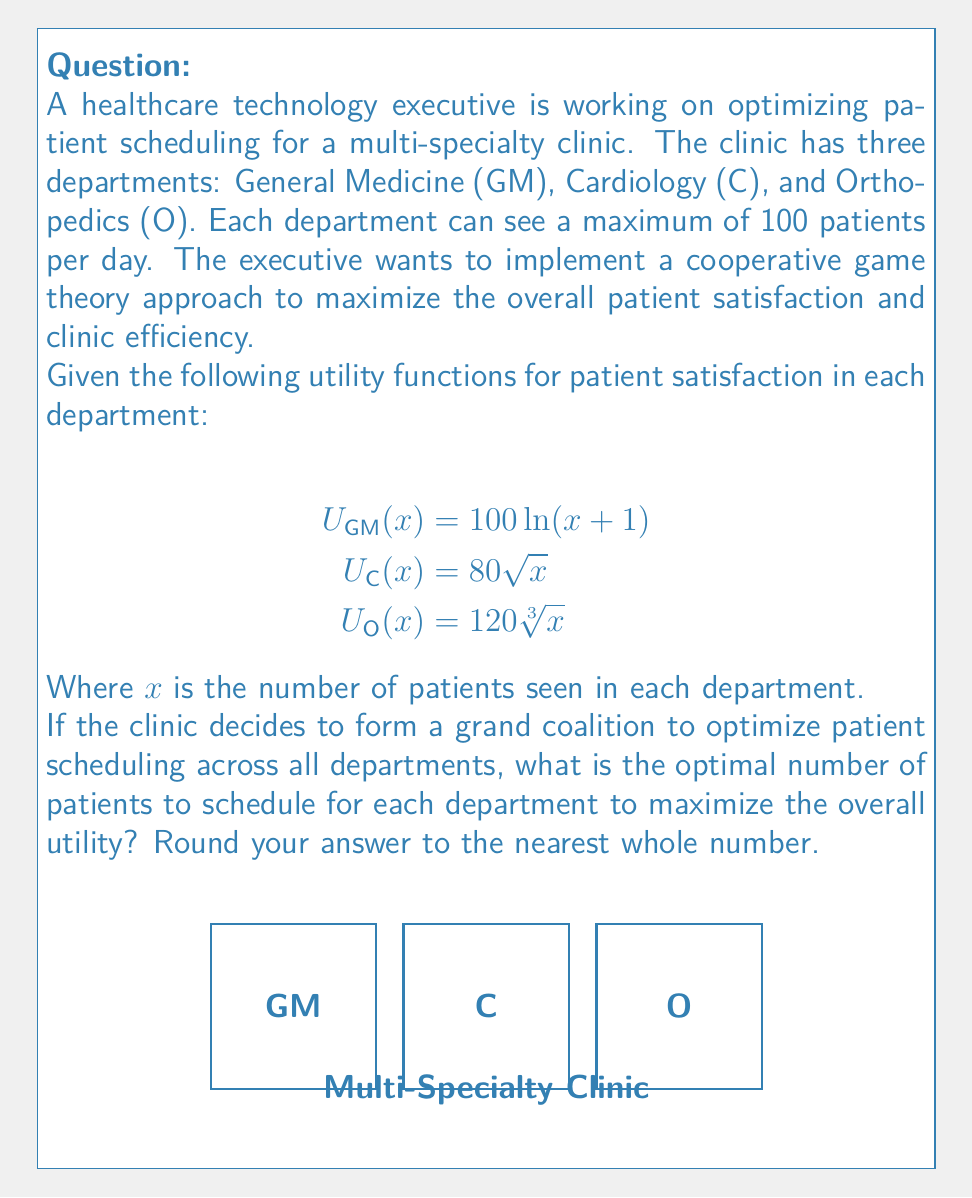Can you solve this math problem? To solve this problem, we need to maximize the total utility function subject to the constraint that the total number of patients seen across all departments cannot exceed 300. Let's approach this step-by-step:

1) Define the total utility function:
   $$U_{total}(x_{GM}, x_C, x_O) = 100\ln(x_{GM}+1) + 80\sqrt{x_C} + 120\sqrt[3]{x_O}$$

2) Set up the optimization problem:
   Maximize $U_{total}(x_{GM}, x_C, x_O)$
   Subject to: $x_{GM} + x_C + x_O \leq 300$
   And: $0 \leq x_{GM}, x_C, x_O \leq 100$

3) Use the method of Lagrange multipliers:
   $$L(x_{GM}, x_C, x_O, \lambda) = 100\ln(x_{GM}+1) + 80\sqrt{x_C} + 120\sqrt[3]{x_O} - \lambda(x_{GM} + x_C + x_O - 300)$$

4) Take partial derivatives and set them to zero:
   $$\frac{\partial L}{\partial x_{GM}} = \frac{100}{x_{GM}+1} - \lambda = 0$$
   $$\frac{\partial L}{\partial x_C} = \frac{40}{\sqrt{x_C}} - \lambda = 0$$
   $$\frac{\partial L}{\partial x_O} = \frac{40}{\sqrt[3]{x_O^2}} - \lambda = 0$$
   $$\frac{\partial L}{\partial \lambda} = x_{GM} + x_C + x_O - 300 = 0$$

5) Solve the system of equations:
   From the first three equations:
   $$x_{GM} = \frac{100}{\lambda} - 1$$
   $$x_C = \frac{1600}{\lambda^2}$$
   $$x_O = \frac{64000}{\lambda^3}$$

6) Substitute these into the constraint equation:
   $$(\frac{100}{\lambda} - 1) + \frac{1600}{\lambda^2} + \frac{64000}{\lambda^3} = 300$$

7) Solve this equation numerically (as it's not easily solvable analytically).
   Using numerical methods, we find that $\lambda \approx 1.8315$

8) Substitute this value back into the expressions for $x_{GM}$, $x_C$, and $x_O$:
   $$x_{GM} \approx 53.6$$
   $$x_C \approx 477.7$$
   $$x_O \approx 104.4$$

9) Since $x_C$ exceeds the department limit of 100, we need to adjust our solution.
   Set $x_C = 100$ and redistribute the remaining patients between GM and O.

10) Repeat steps 3-8 with the new constraint $x_{GM} + x_O = 200$
    This gives us:
    $$x_{GM} \approx 85.7$$
    $$x_O \approx 114.3$$

11) Round to the nearest whole number:
    $x_{GM} = 86$, $x_C = 100$, $x_O = 114$

Therefore, the optimal number of patients to schedule for each department is 86 for General Medicine, 100 for Cardiology, and 114 for Orthopedics.
Answer: GM: 86, C: 100, O: 114 